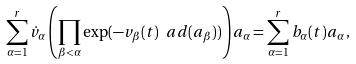<formula> <loc_0><loc_0><loc_500><loc_500>\sum _ { \alpha = 1 } ^ { r } \dot { v } _ { \alpha } \left ( \prod _ { \beta < \alpha } \exp ( - v _ { \beta } ( t ) \ a d ( a _ { \beta } ) ) \right ) a _ { \alpha } = \sum _ { \alpha = 1 } ^ { r } b _ { \alpha } ( t ) a _ { \alpha } \, ,</formula> 